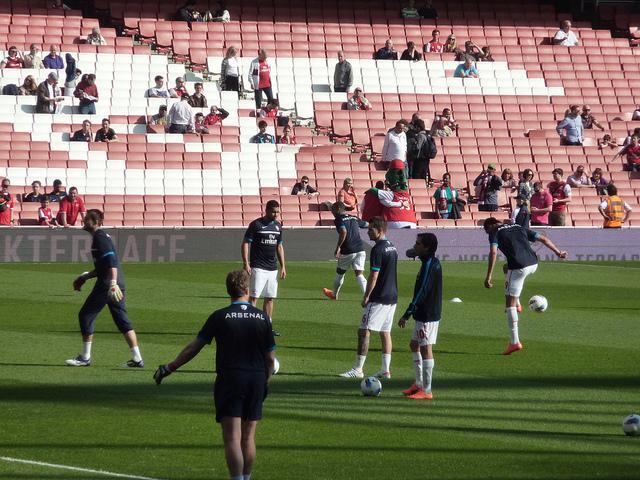How many players are on the field?
Give a very brief answer. 7. How many people can be seen?
Give a very brief answer. 8. How many televisions sets in the picture are turned on?
Give a very brief answer. 0. 